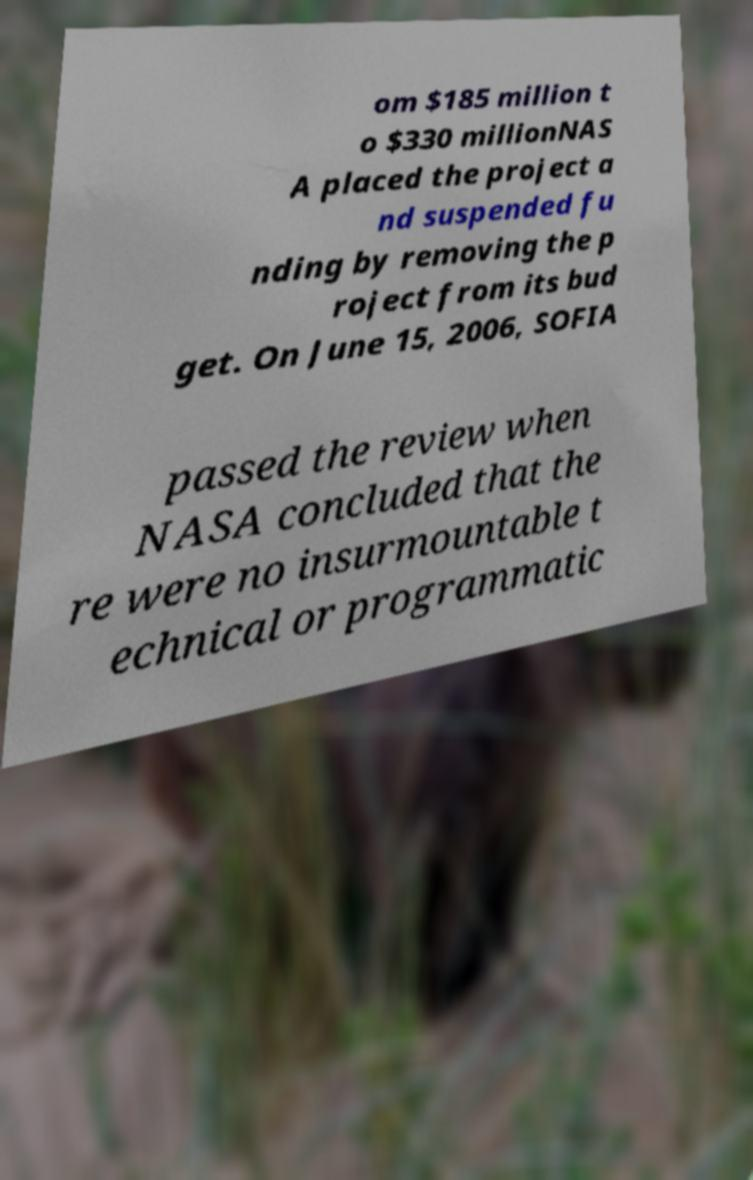Please read and relay the text visible in this image. What does it say? om $185 million t o $330 millionNAS A placed the project a nd suspended fu nding by removing the p roject from its bud get. On June 15, 2006, SOFIA passed the review when NASA concluded that the re were no insurmountable t echnical or programmatic 